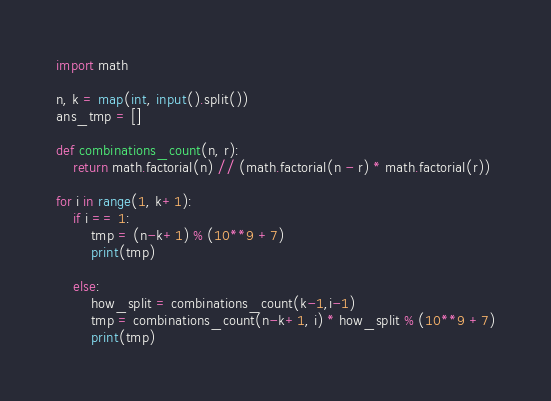Convert code to text. <code><loc_0><loc_0><loc_500><loc_500><_Python_>import math

n, k = map(int, input().split())
ans_tmp = []

def combinations_count(n, r):
    return math.factorial(n) // (math.factorial(n - r) * math.factorial(r))

for i in range(1, k+1):
    if i == 1:
        tmp = (n-k+1) % (10**9 +7)
        print(tmp)       

    else:
        how_split = combinations_count(k-1,i-1)
        tmp = combinations_count(n-k+1, i) * how_split % (10**9 +7)
        print(tmp)</code> 